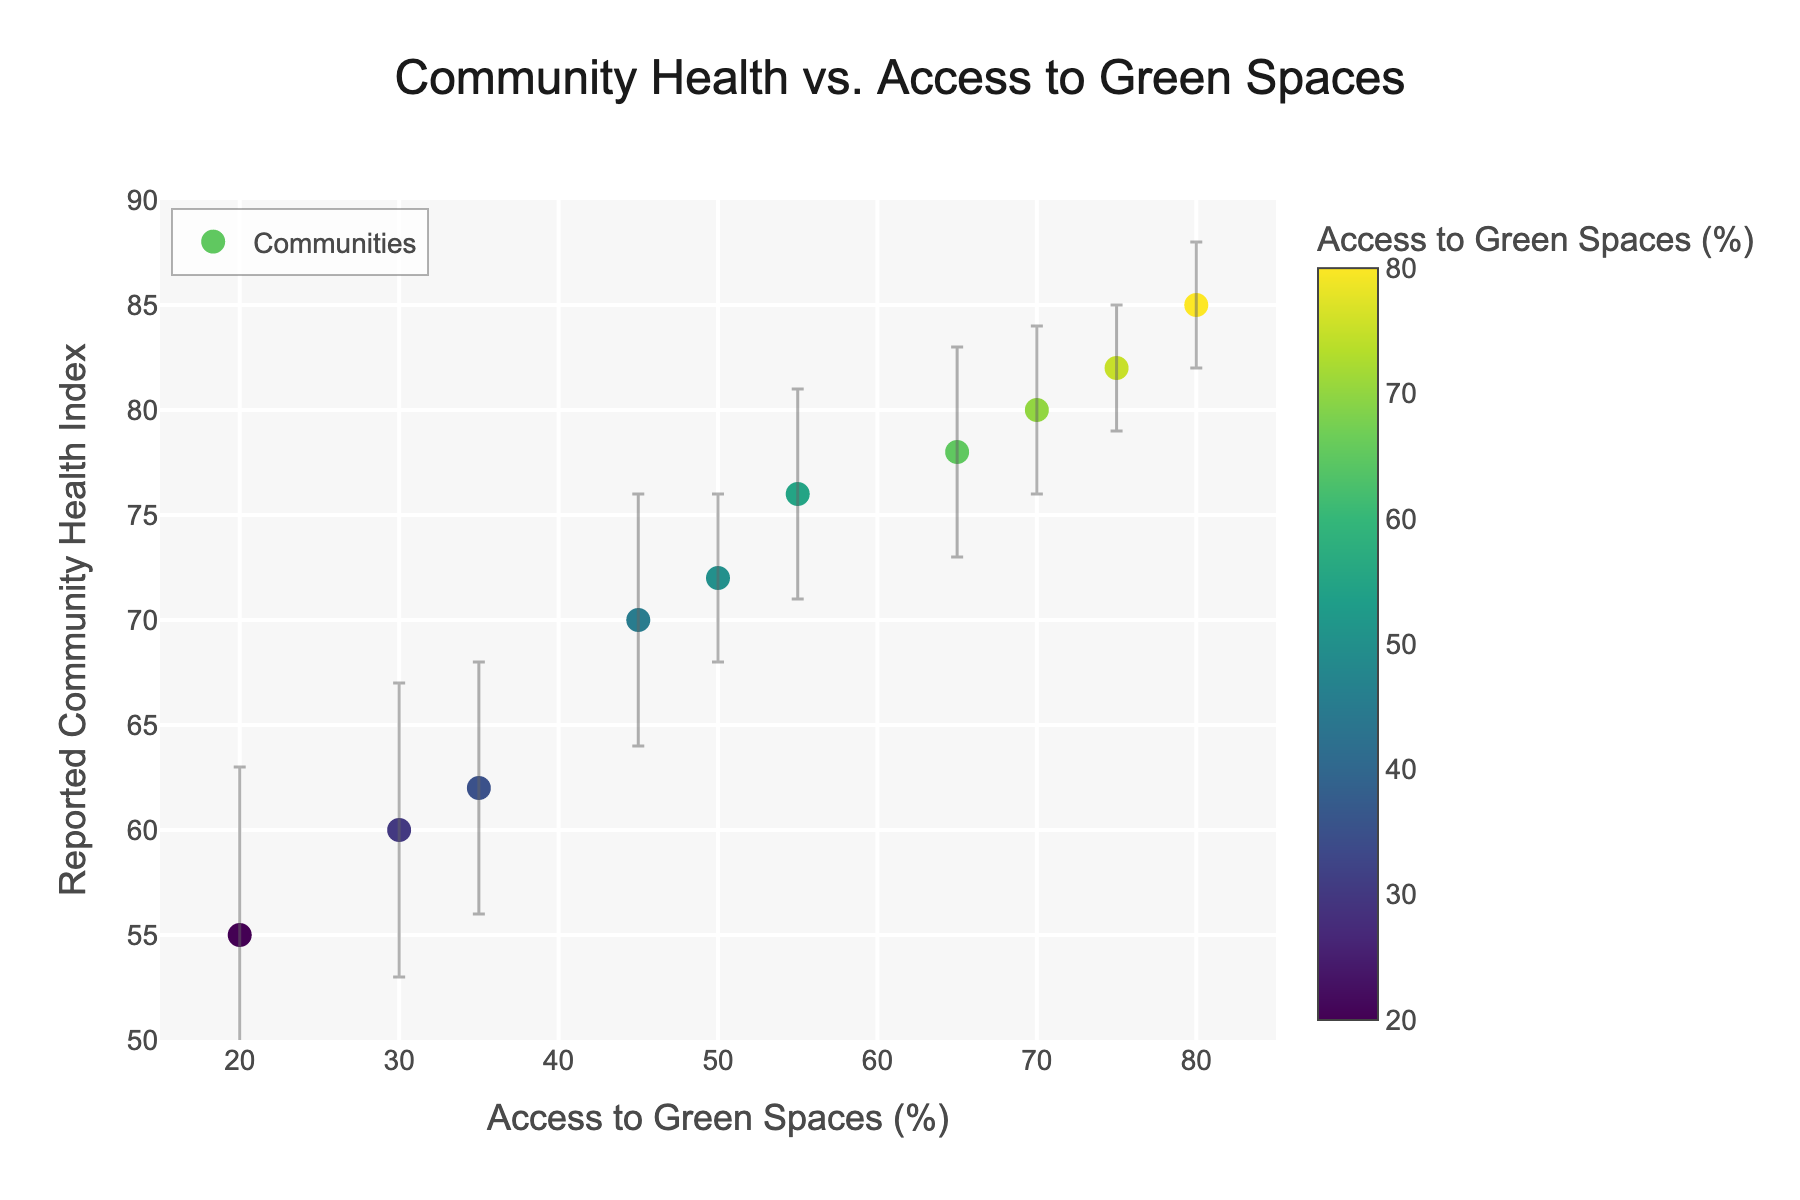How many communities are represented in the figure? Count the number of data points (markers) on the scatter plot. Each marker represents one community.
Answer: 10 What is the title of the figure? Look at the top center of the figure to find the title.
Answer: Community Health vs. Access to Green Spaces Which community has the highest reported community health index? Identify the marker that is highest on the y-axis and note the community from the hover text.
Answer: Greenfield What is the range of access to green spaces (%) displayed in the figure? Look at the x-axis to find the minimum and maximum values.
Answer: 20% to 80% How does the reported health index of Sunvalley compare to Brookside? Find the y-values for Sunvalley and Brookside. Compare the two values.
Answer: Sunvalley has a higher health index than Brookside Which community has the largest standard deviation in reported community health index? Look at the length of the error bars for each marker and identify the longest one.
Answer: Havenpark What is the general trend observed between access to green spaces and reported community health index? Observe the overall distribution of data points; higher access to green spaces correlates with a higher health index.
Answer: Positive correlation What's the average reported community health index for communities with access to green spaces greater than 50%? Identify the health indexes for communities with access > 50% and compute their average: (78 + 85 + 80 + 76 + 82) / 5 = 80.2
Answer: 80.2 Which community has the lowest access to green spaces and what is their reported health index? Identify the marker at the furthest left on the x-axis and note the community and its health index from the hover text.
Answer: Havenpark, 55 